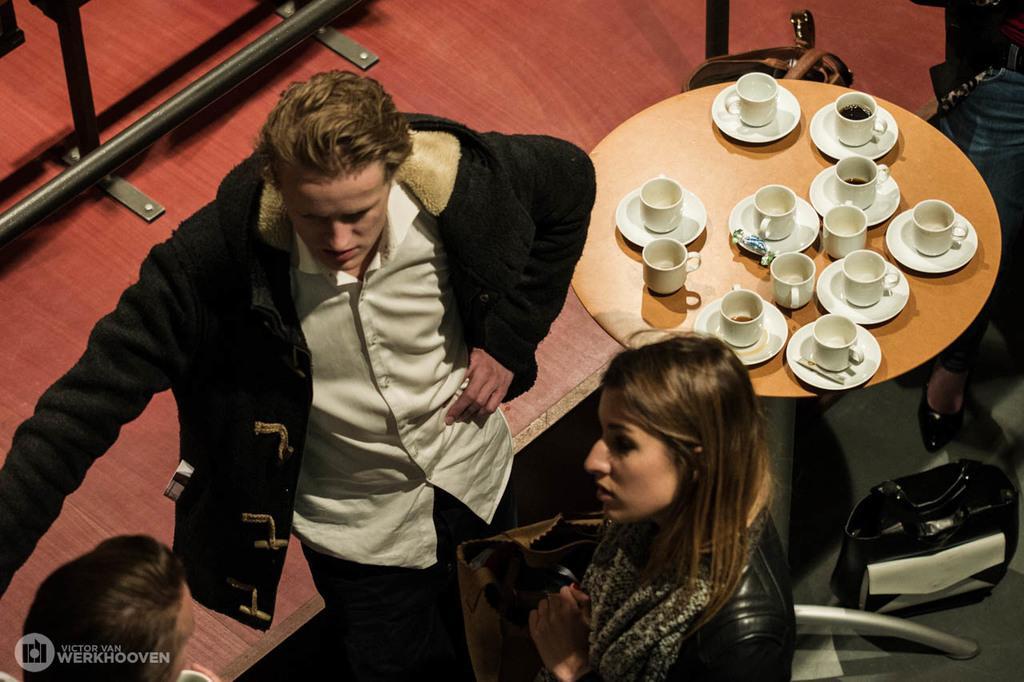Describe this image in one or two sentences. In this picture we can see a man and a women. This is table. On the table there are cups and saucers. 